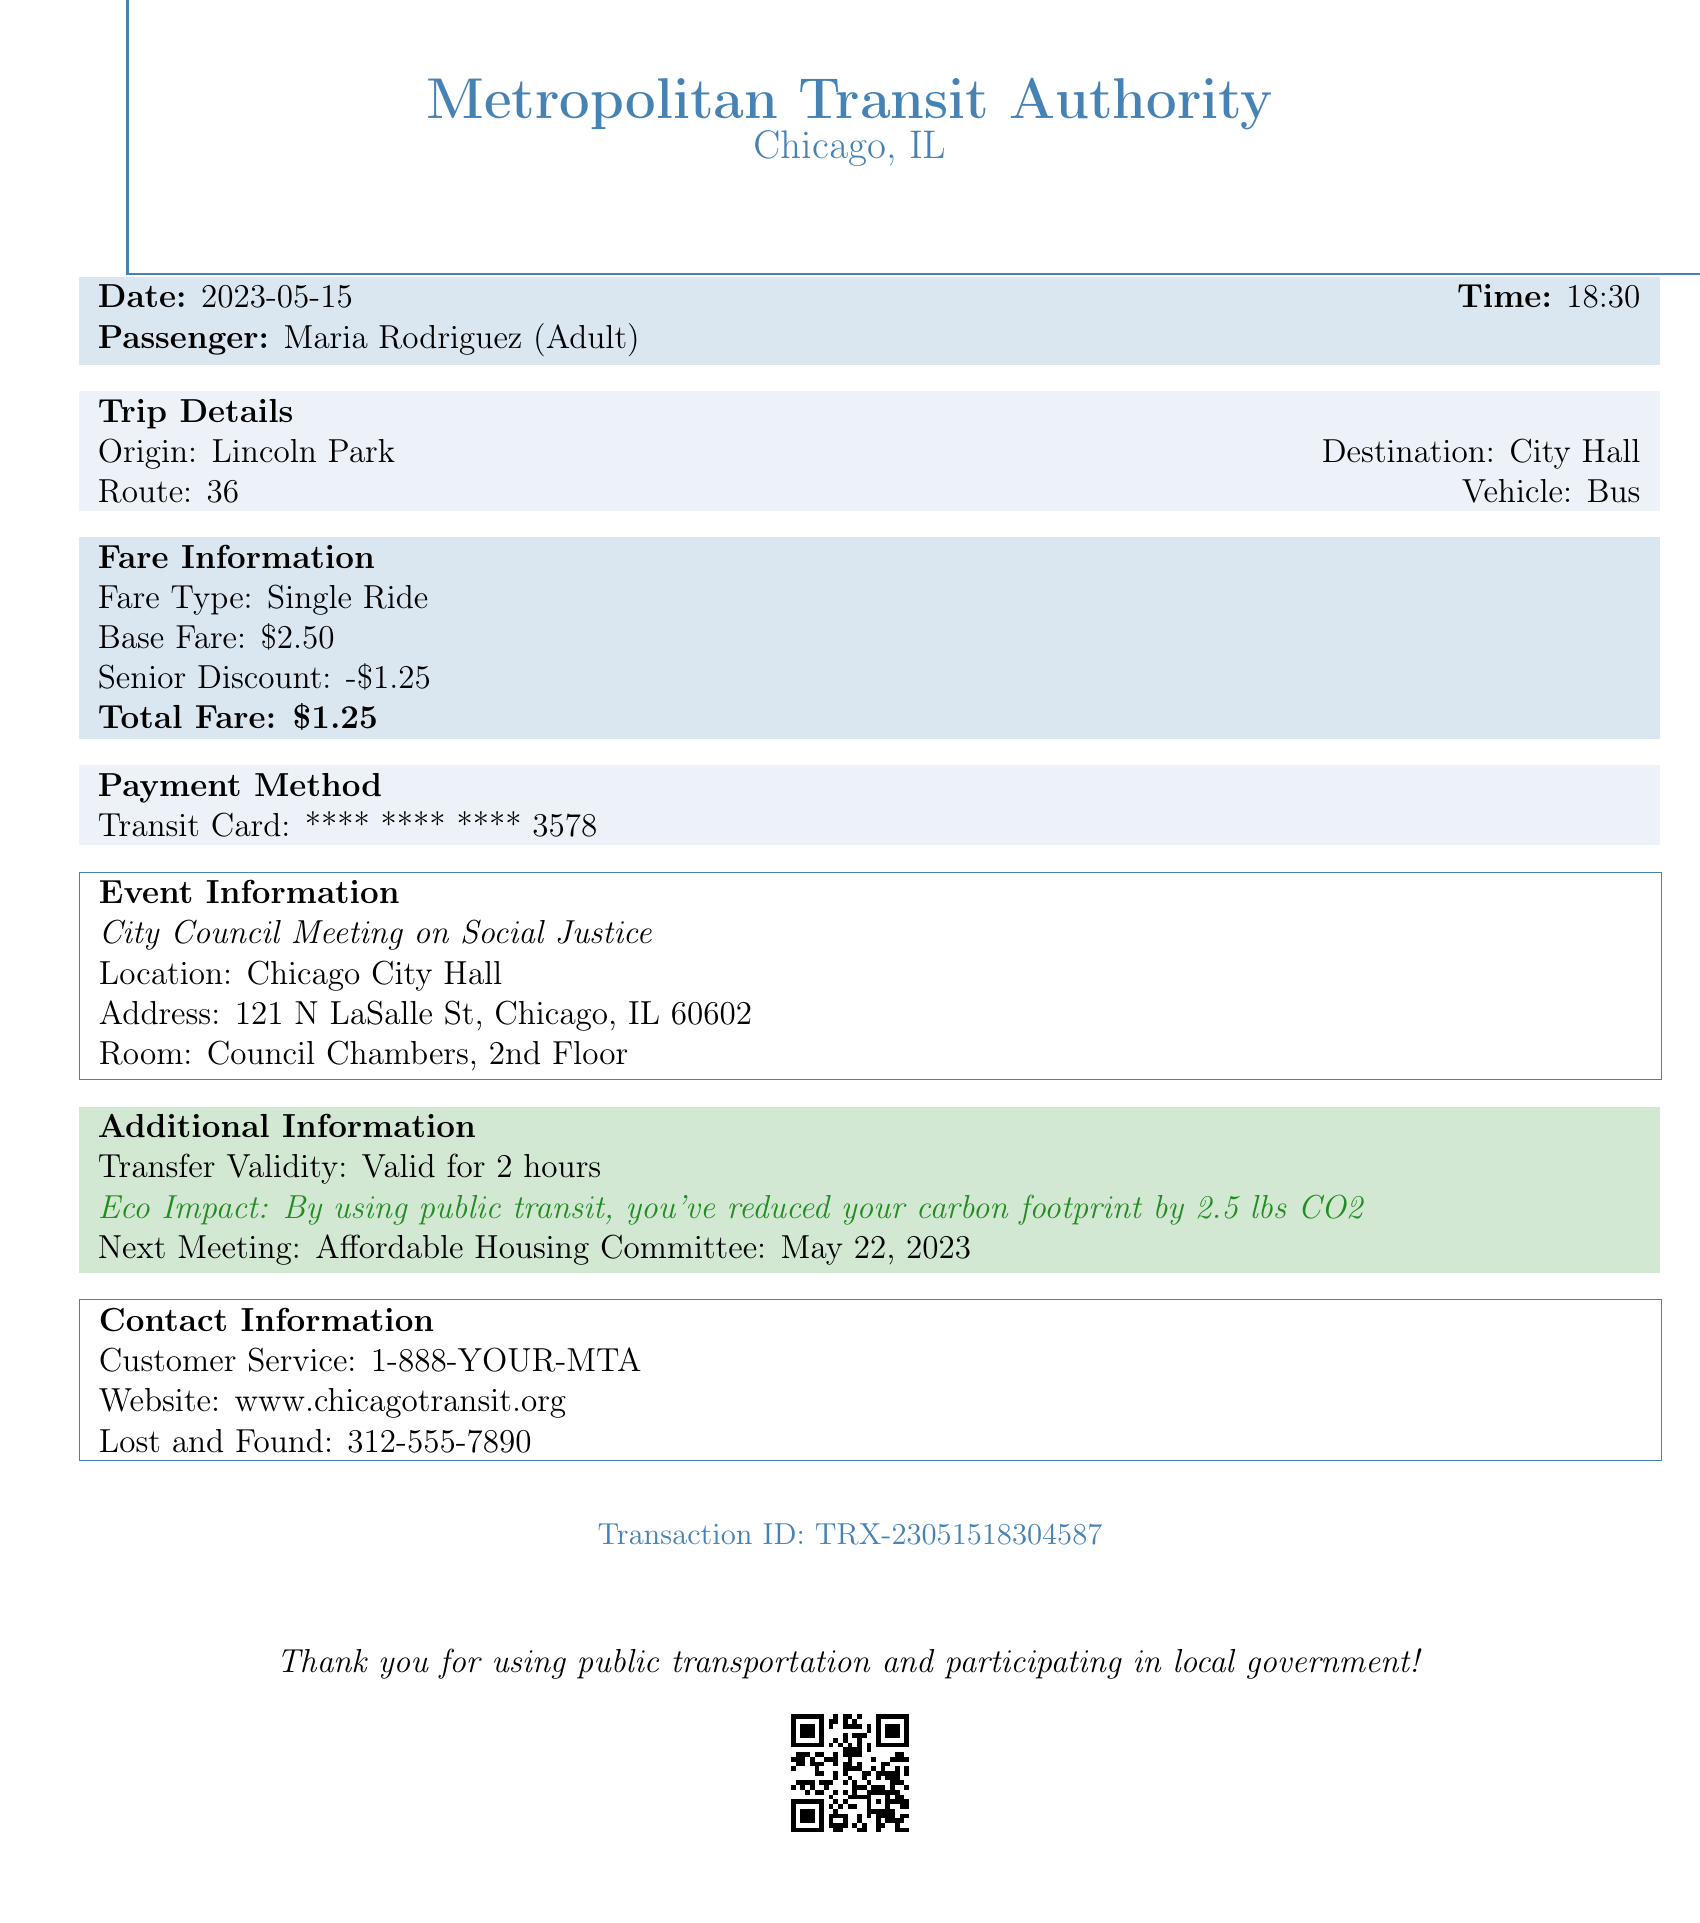What is the date of the receipt? The date of the receipt is stated in the document under receipt_header.
Answer: 2023-05-15 What is the total fare paid? The total fare is mentioned in the fare_info section of the document.
Answer: $1.25 Who is the passenger? The passenger's name is provided in the passenger_info segment.
Answer: Maria Rodriguez What is the origin of the trip? The trip's origin is indicated in the trip_details section.
Answer: Lincoln Park What is the vehicle type used for the trip? The vehicle type is mentioned in the trip_details section of the document.
Answer: Bus What is the event name listed in the document? The event name is found in the event_info part of the receipt.
Answer: City Council Meeting on Social Justice What discount was applied to the fare? The discount is specified in the fare_info section, indicating how much was deducted.
Answer: -$1.25 How long is the transfer validity? The transfer validity is noted in the additional_info section.
Answer: 2 hours What is the next meeting mentioned? The upcoming meeting is detailed in the additional_info section.
Answer: Affordable Housing Committee: May 22, 2023 